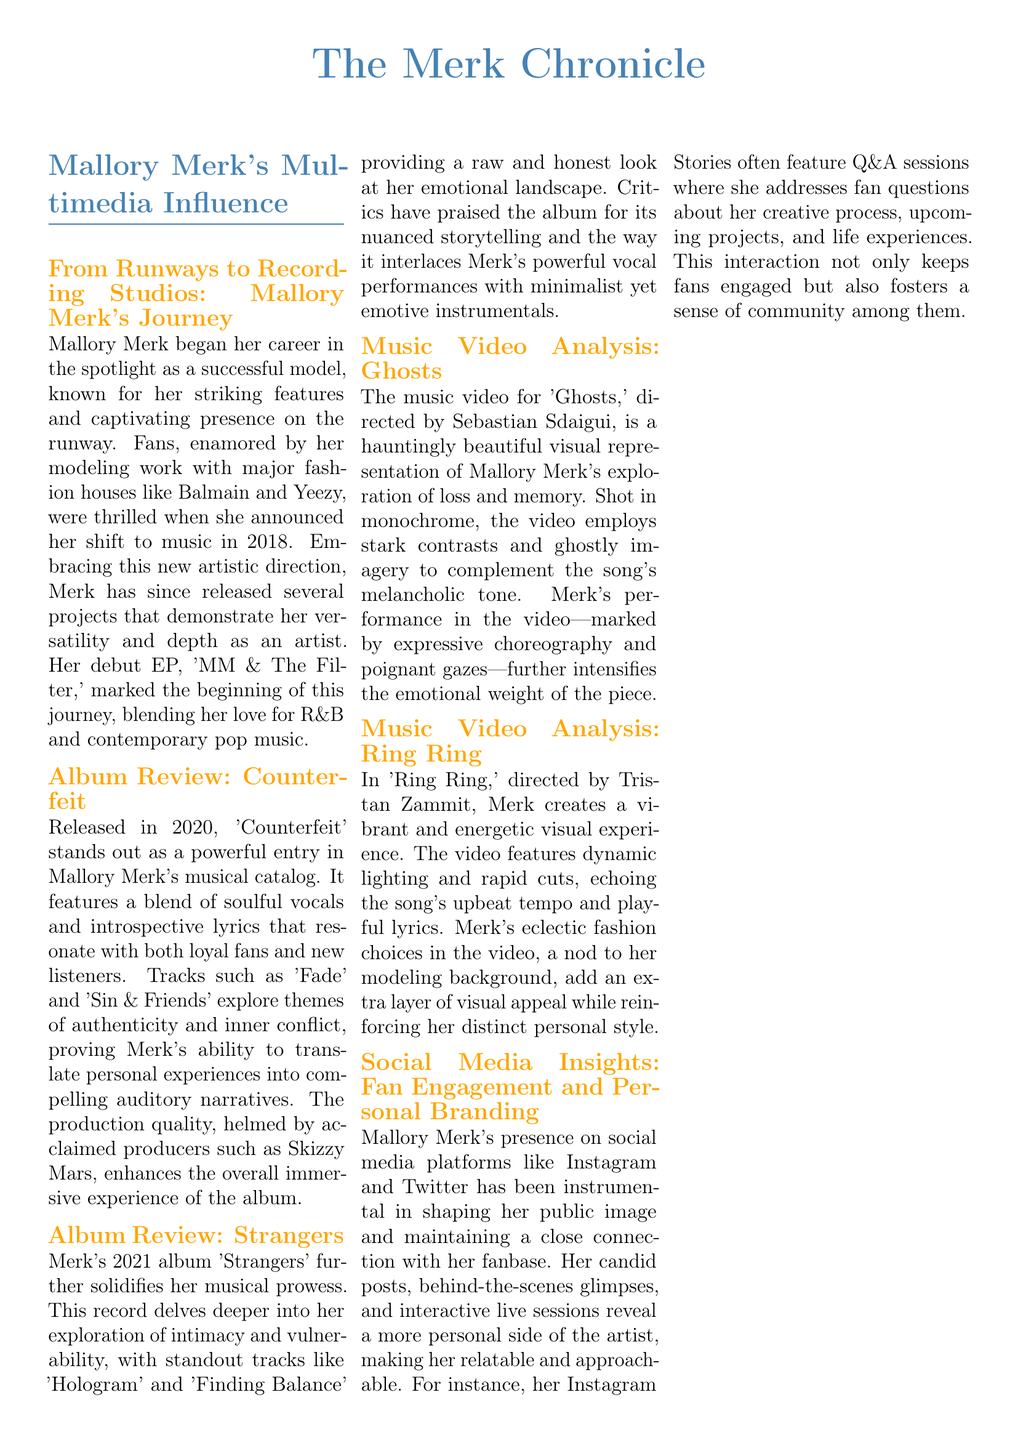What is the title of Mallory Merk's debut EP? The document states that her debut EP is titled 'MM & The Filter.'
Answer: 'MM & The Filter' In what year was the album 'Counterfeit' released? The document mentions that 'Counterfeit' was released in 2020.
Answer: 2020 Which track from the album 'Strangers' explores intimacy and vulnerability? The document lists 'Hologram' and 'Finding Balance' as standout tracks exploring intimacy and vulnerability.
Answer: 'Hologram' and 'Finding Balance' Who directed the music video for 'Ghosts'? The document states that the music video for 'Ghosts' was directed by Sebastian Sdaigui.
Answer: Sebastian Sdaigui What social media platforms are mentioned as important for Mallory Merk's fan engagement? The document mentions Instagram and Twitter as key platforms for her fan engagement.
Answer: Instagram and Twitter What aspect of Mallory's fashion is highlighted in the fan corner? The fan corner discusses her fashion evolution and ability to blend haute couture with street style.
Answer: Fashion evolution and blending styles How many favorite Mallory moments are listed in the document? The document lists four favorite Mallory moments in the fan corner.
Answer: Four What event is mentioned as part of Mallory's Summer Tour 2023? The upcoming events section mentions the Summer Tour 2023 but does not specify an individual event.
Answer: Summer Tour 2023 Which famous show will Mallory make a guest appearance on? The upcoming events section states that she will make a guest appearance on "The Tonight Show."
Answer: "The Tonight Show" 